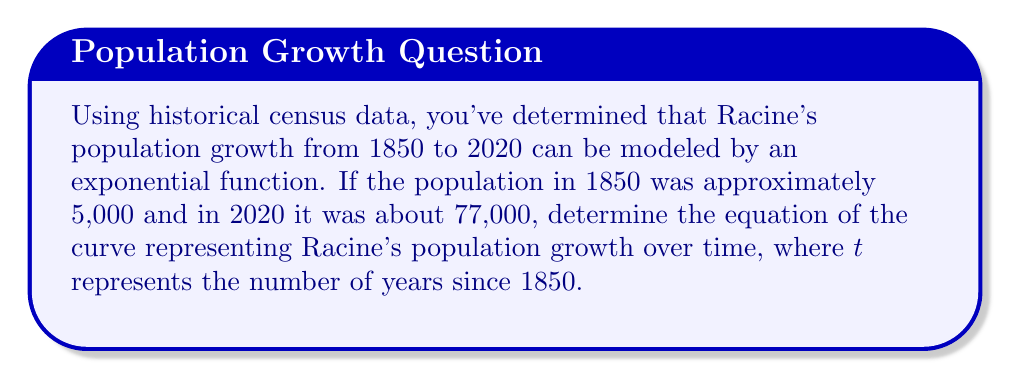Can you answer this question? Let's approach this step-by-step:

1) The general form of an exponential growth function is:
   $P(t) = P_0 \cdot e^{rt}$
   where $P_0$ is the initial population, $r$ is the growth rate, and $t$ is time.

2) We know two points on this curve:
   At $t = 0$ (1850), $P = 5,000$
   At $t = 170$ (2020), $P = 77,000$

3) Let's use these to set up an equation:
   $77,000 = 5,000 \cdot e^{170r}$

4) Divide both sides by 5,000:
   $15.4 = e^{170r}$

5) Take the natural log of both sides:
   $\ln(15.4) = 170r$

6) Solve for $r$:
   $r = \frac{\ln(15.4)}{170} \approx 0.016$

7) Now we have all the components of our equation:
   $P_0 = 5,000$
   $r \approx 0.016$

8) Substituting these into our general form:
   $P(t) = 5,000 \cdot e^{0.016t}$

This equation represents Racine's population $t$ years after 1850.
Answer: $P(t) = 5,000 \cdot e^{0.016t}$ 